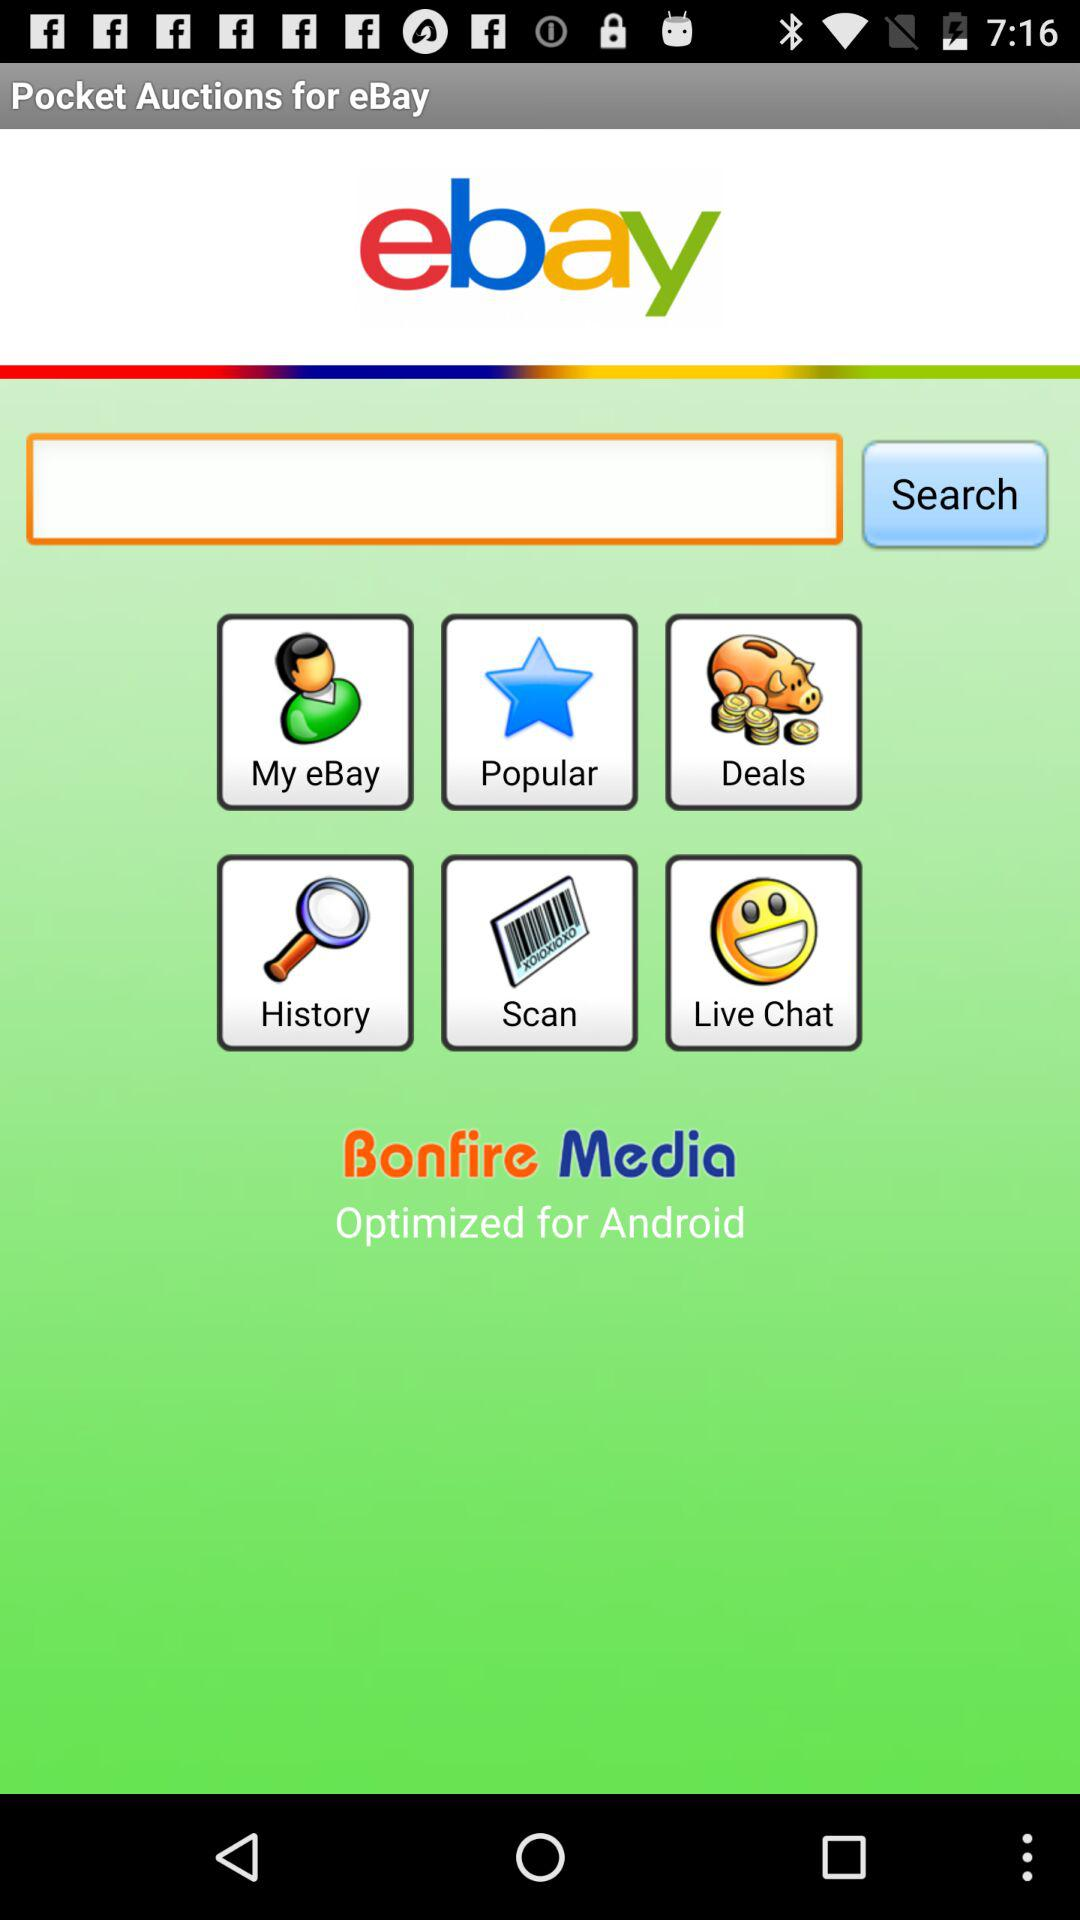What is the application name? The application name is "ebay". 